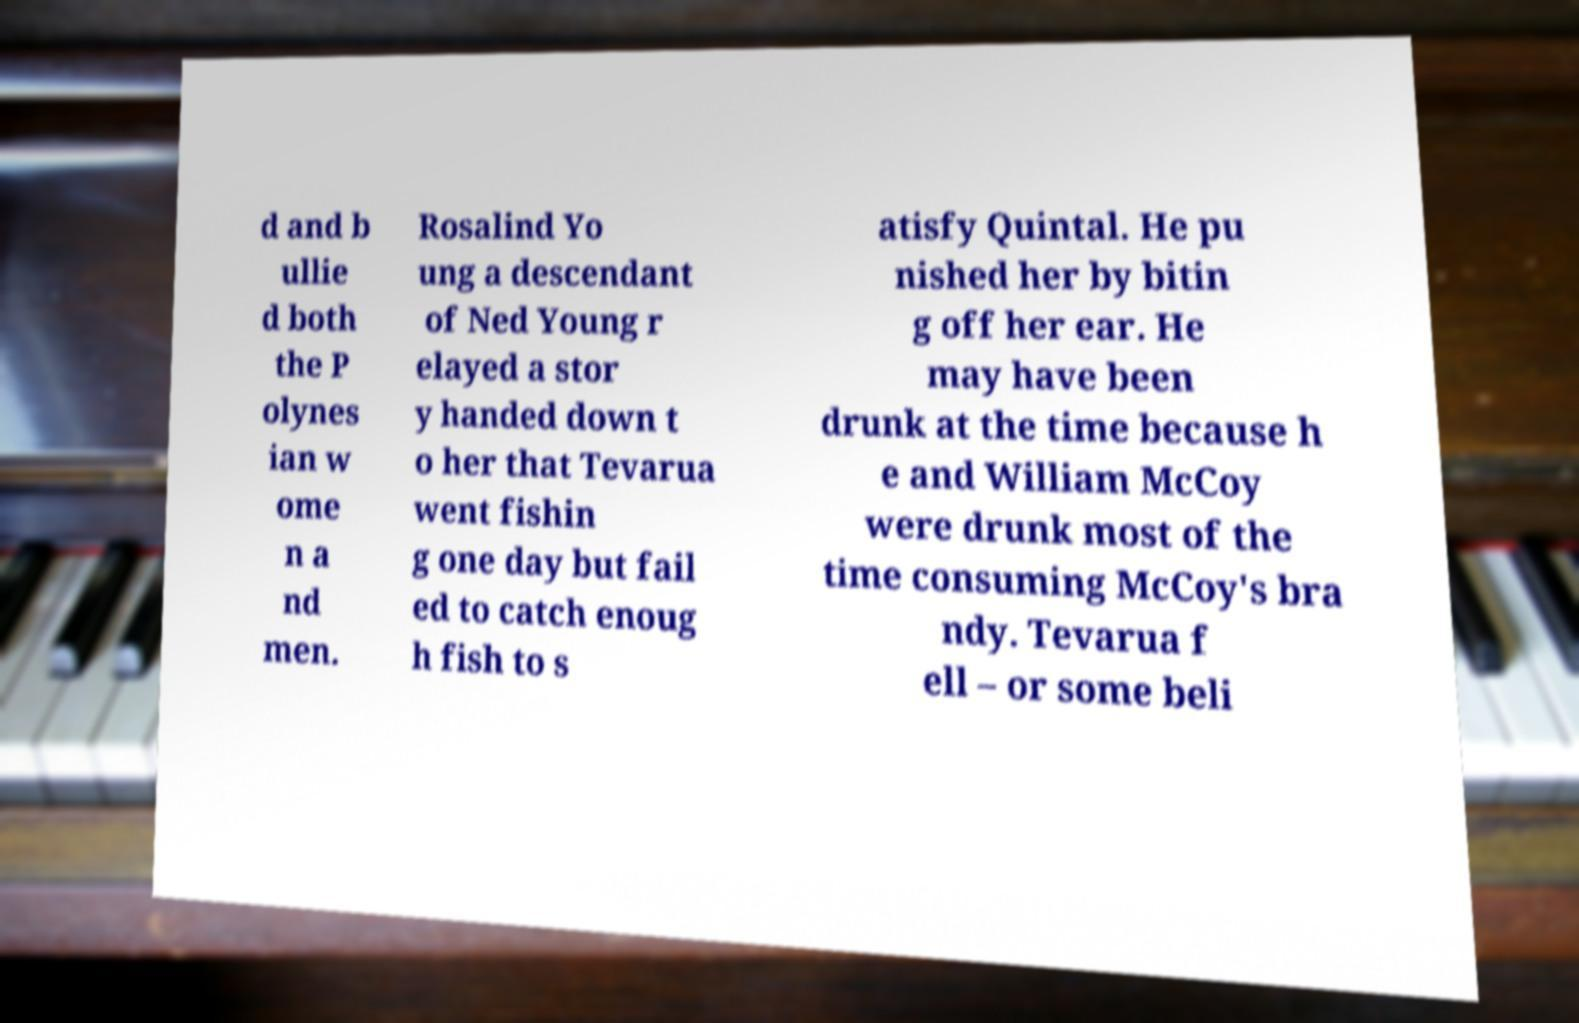Could you extract and type out the text from this image? d and b ullie d both the P olynes ian w ome n a nd men. Rosalind Yo ung a descendant of Ned Young r elayed a stor y handed down t o her that Tevarua went fishin g one day but fail ed to catch enoug h fish to s atisfy Quintal. He pu nished her by bitin g off her ear. He may have been drunk at the time because h e and William McCoy were drunk most of the time consuming McCoy's bra ndy. Tevarua f ell – or some beli 